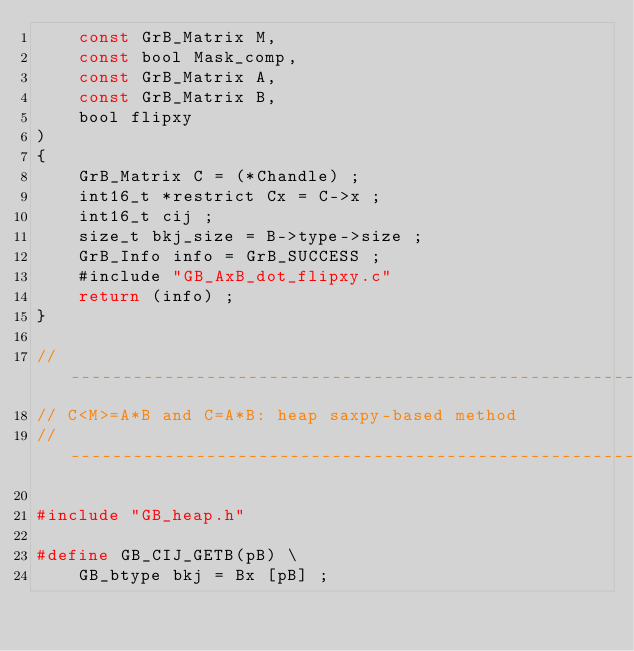Convert code to text. <code><loc_0><loc_0><loc_500><loc_500><_C_>    const GrB_Matrix M,
    const bool Mask_comp,
    const GrB_Matrix A,
    const GrB_Matrix B,
    bool flipxy
)
{ 
    GrB_Matrix C = (*Chandle) ;
    int16_t *restrict Cx = C->x ;
    int16_t cij ;
    size_t bkj_size = B->type->size ;
    GrB_Info info = GrB_SUCCESS ;
    #include "GB_AxB_dot_flipxy.c"
    return (info) ;
}

//------------------------------------------------------------------------------
// C<M>=A*B and C=A*B: heap saxpy-based method
//------------------------------------------------------------------------------

#include "GB_heap.h"

#define GB_CIJ_GETB(pB) \
    GB_btype bkj = Bx [pB] ;
</code> 